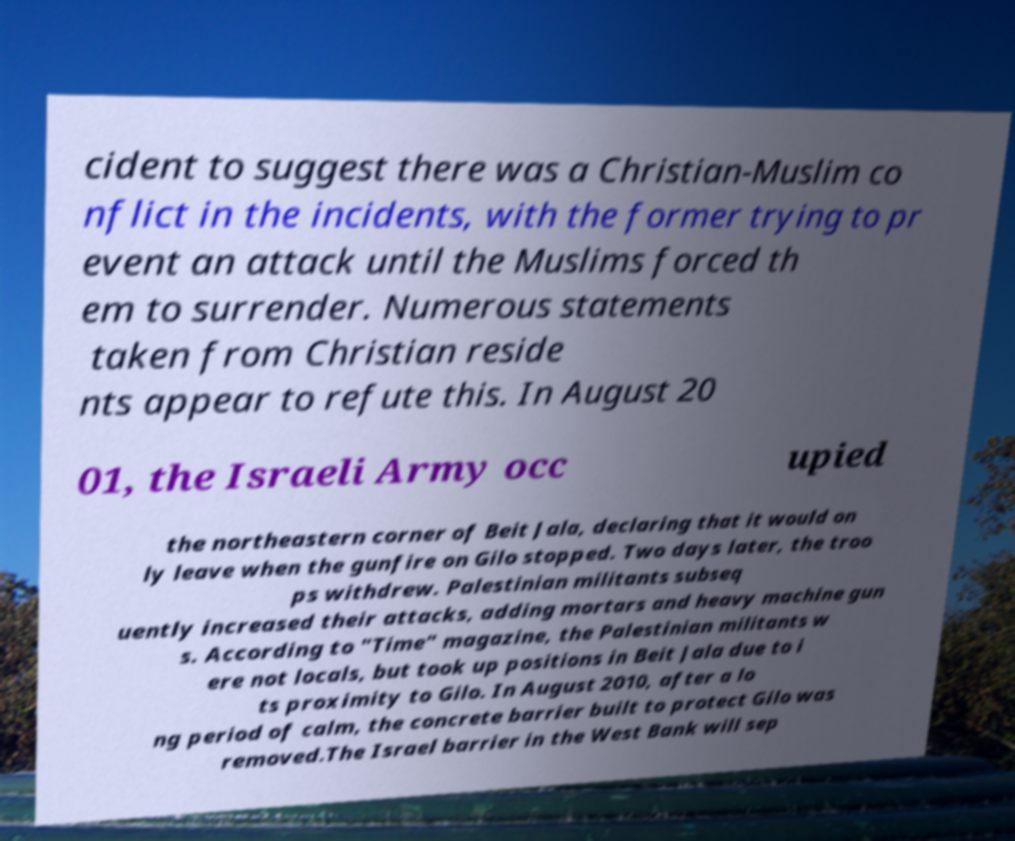What messages or text are displayed in this image? I need them in a readable, typed format. cident to suggest there was a Christian-Muslim co nflict in the incidents, with the former trying to pr event an attack until the Muslims forced th em to surrender. Numerous statements taken from Christian reside nts appear to refute this. In August 20 01, the Israeli Army occ upied the northeastern corner of Beit Jala, declaring that it would on ly leave when the gunfire on Gilo stopped. Two days later, the troo ps withdrew. Palestinian militants subseq uently increased their attacks, adding mortars and heavy machine gun s. According to "Time" magazine, the Palestinian militants w ere not locals, but took up positions in Beit Jala due to i ts proximity to Gilo. In August 2010, after a lo ng period of calm, the concrete barrier built to protect Gilo was removed.The Israel barrier in the West Bank will sep 